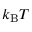<formula> <loc_0><loc_0><loc_500><loc_500>k _ { B } T</formula> 